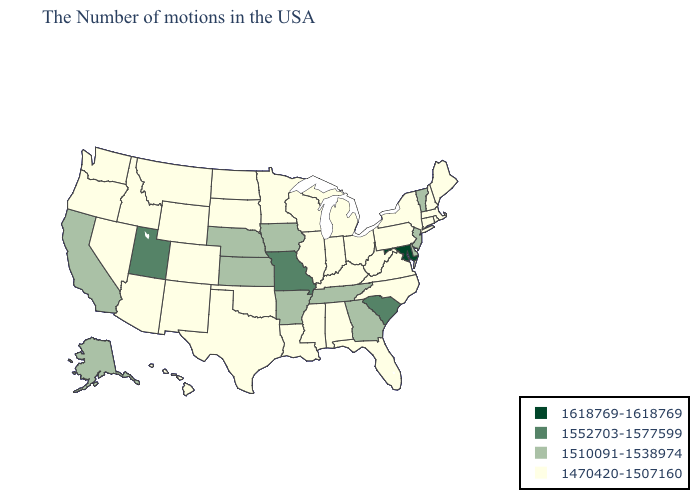What is the lowest value in the USA?
Quick response, please. 1470420-1507160. Name the states that have a value in the range 1470420-1507160?
Concise answer only. Maine, Massachusetts, Rhode Island, New Hampshire, Connecticut, New York, Pennsylvania, Virginia, North Carolina, West Virginia, Ohio, Florida, Michigan, Kentucky, Indiana, Alabama, Wisconsin, Illinois, Mississippi, Louisiana, Minnesota, Oklahoma, Texas, South Dakota, North Dakota, Wyoming, Colorado, New Mexico, Montana, Arizona, Idaho, Nevada, Washington, Oregon, Hawaii. Name the states that have a value in the range 1552703-1577599?
Give a very brief answer. South Carolina, Missouri, Utah. Which states have the highest value in the USA?
Short answer required. Maryland. What is the lowest value in the South?
Concise answer only. 1470420-1507160. Among the states that border Vermont , which have the lowest value?
Answer briefly. Massachusetts, New Hampshire, New York. Name the states that have a value in the range 1552703-1577599?
Give a very brief answer. South Carolina, Missouri, Utah. How many symbols are there in the legend?
Quick response, please. 4. What is the value of West Virginia?
Keep it brief. 1470420-1507160. Which states have the lowest value in the USA?
Quick response, please. Maine, Massachusetts, Rhode Island, New Hampshire, Connecticut, New York, Pennsylvania, Virginia, North Carolina, West Virginia, Ohio, Florida, Michigan, Kentucky, Indiana, Alabama, Wisconsin, Illinois, Mississippi, Louisiana, Minnesota, Oklahoma, Texas, South Dakota, North Dakota, Wyoming, Colorado, New Mexico, Montana, Arizona, Idaho, Nevada, Washington, Oregon, Hawaii. Does Idaho have the lowest value in the USA?
Short answer required. Yes. Among the states that border Iowa , does Missouri have the lowest value?
Keep it brief. No. Does Indiana have the same value as Montana?
Write a very short answer. Yes. What is the value of Arizona?
Keep it brief. 1470420-1507160. What is the highest value in the Northeast ?
Short answer required. 1510091-1538974. 